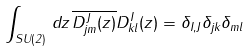<formula> <loc_0><loc_0><loc_500><loc_500>\int _ { S U ( 2 ) } \, d z \, \overline { D ^ { J } _ { j m } ( z ) } D ^ { I } _ { k l } ( z ) = \delta _ { I , J } \delta _ { j k } \delta _ { m l }</formula> 